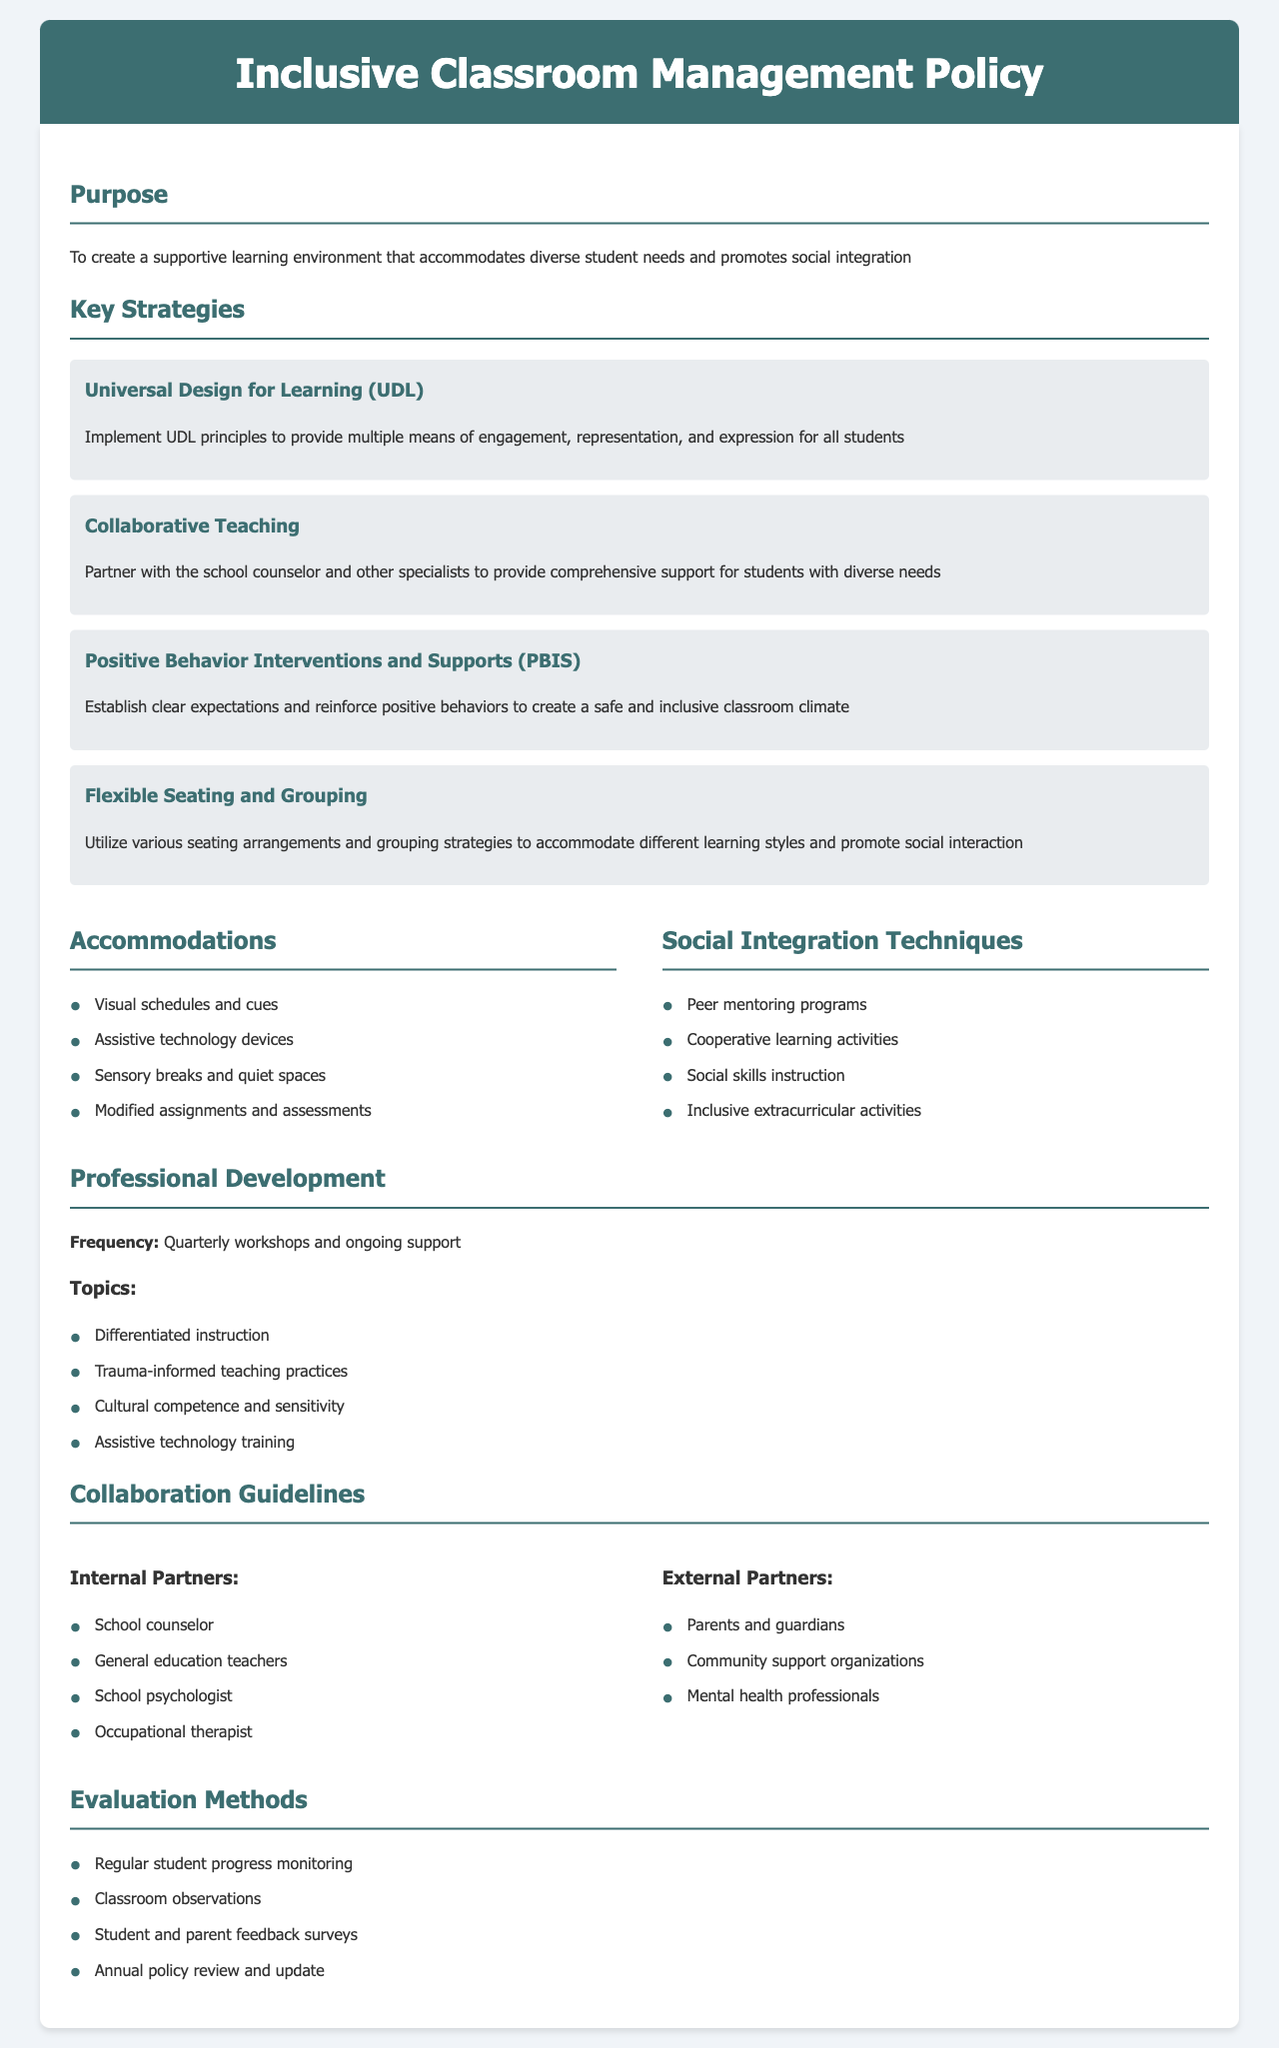what is the purpose of the policy? The purpose outlines the goal of the policy, which is to create a supportive learning environment that accommodates diverse student needs and promotes social integration.
Answer: supportive learning environment how often are professional development workshops scheduled? The frequency of professional development workshops is specified in the document, which states they occur quarterly.
Answer: Quarterly what strategy involves providing multiple means of engagement? The document mentions Universal Design for Learning (UDL) as the strategy that focuses on providing multiple means of engagement, representation, and expression.
Answer: Universal Design for Learning (UDL) name one type of accommodation listed in the document. The document provides several accommodations, one of which is visual schedules and cues.
Answer: visual schedules and cues what are peer mentoring programs categorized as? The document specifies peer mentoring programs as a technique for social integration, falling under Social Integration Techniques.
Answer: Social Integration Techniques who are considered internal partners for collaboration? The document lists several internal partners, one of which is the school counselor as part of the collaboration guidelines.
Answer: school counselor what evaluation method includes feedback from parents? The method mentioned for evaluation that includes input from parents is the student and parent feedback surveys.
Answer: student and parent feedback surveys which strategy emphasizes positive behavior reinforcement? The strategy detailed in the document that focuses on positive behavior reinforcement is Positive Behavior Interventions and Supports (PBIS).
Answer: Positive Behavior Interventions and Supports (PBIS) 